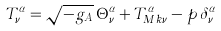<formula> <loc_0><loc_0><loc_500><loc_500>T ^ { \alpha } _ { \nu } = \sqrt { - g _ { A } } \, \Theta ^ { \alpha } _ { \nu } + T _ { M k \nu } ^ { \alpha } - p \, \delta _ { \nu } ^ { \alpha }</formula> 